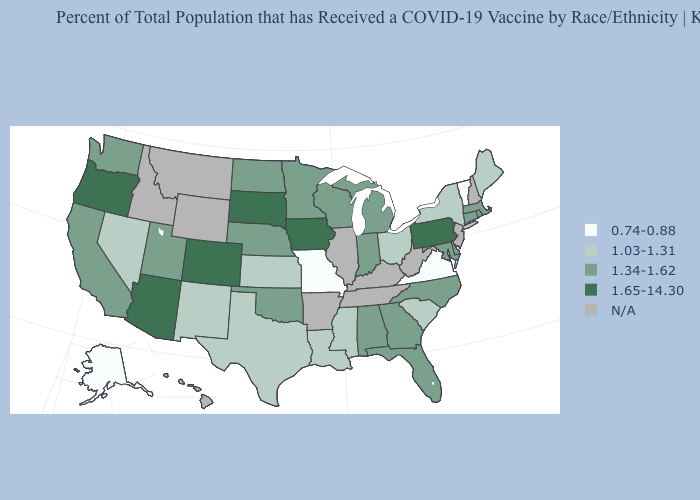How many symbols are there in the legend?
Short answer required. 5. What is the value of Wyoming?
Give a very brief answer. N/A. Name the states that have a value in the range N/A?
Answer briefly. Arkansas, Hawaii, Idaho, Illinois, Kentucky, Montana, New Hampshire, New Jersey, Tennessee, West Virginia, Wyoming. What is the lowest value in states that border Virginia?
Short answer required. 1.34-1.62. What is the value of Minnesota?
Keep it brief. 1.34-1.62. Name the states that have a value in the range 1.65-14.30?
Concise answer only. Arizona, Colorado, Iowa, Oregon, Pennsylvania, South Dakota. What is the value of Montana?
Be succinct. N/A. What is the value of Nebraska?
Answer briefly. 1.34-1.62. Name the states that have a value in the range N/A?
Concise answer only. Arkansas, Hawaii, Idaho, Illinois, Kentucky, Montana, New Hampshire, New Jersey, Tennessee, West Virginia, Wyoming. Name the states that have a value in the range 1.34-1.62?
Give a very brief answer. Alabama, California, Connecticut, Delaware, Florida, Georgia, Indiana, Maryland, Massachusetts, Michigan, Minnesota, Nebraska, North Carolina, North Dakota, Oklahoma, Rhode Island, Utah, Washington, Wisconsin. Among the states that border Colorado , does Kansas have the lowest value?
Be succinct. Yes. What is the value of Ohio?
Answer briefly. 1.03-1.31. Among the states that border Alabama , which have the highest value?
Keep it brief. Florida, Georgia. Which states hav the highest value in the West?
Write a very short answer. Arizona, Colorado, Oregon. 